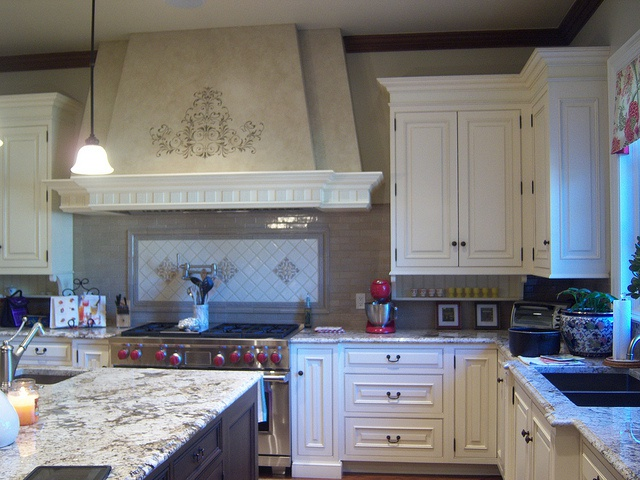Describe the objects in this image and their specific colors. I can see dining table in gray, lightgray, darkgray, and black tones, oven in gray, black, navy, and maroon tones, potted plant in gray, black, navy, and blue tones, sink in gray, black, navy, and blue tones, and bottle in gray, black, and darkblue tones in this image. 